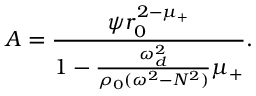<formula> <loc_0><loc_0><loc_500><loc_500>A = \frac { \psi r _ { 0 } ^ { 2 - \mu _ { + } } } { 1 - \frac { \omega _ { d } ^ { 2 } } { \rho _ { 0 } ( \omega ^ { 2 } - N ^ { 2 } ) } \mu _ { + } } .</formula> 